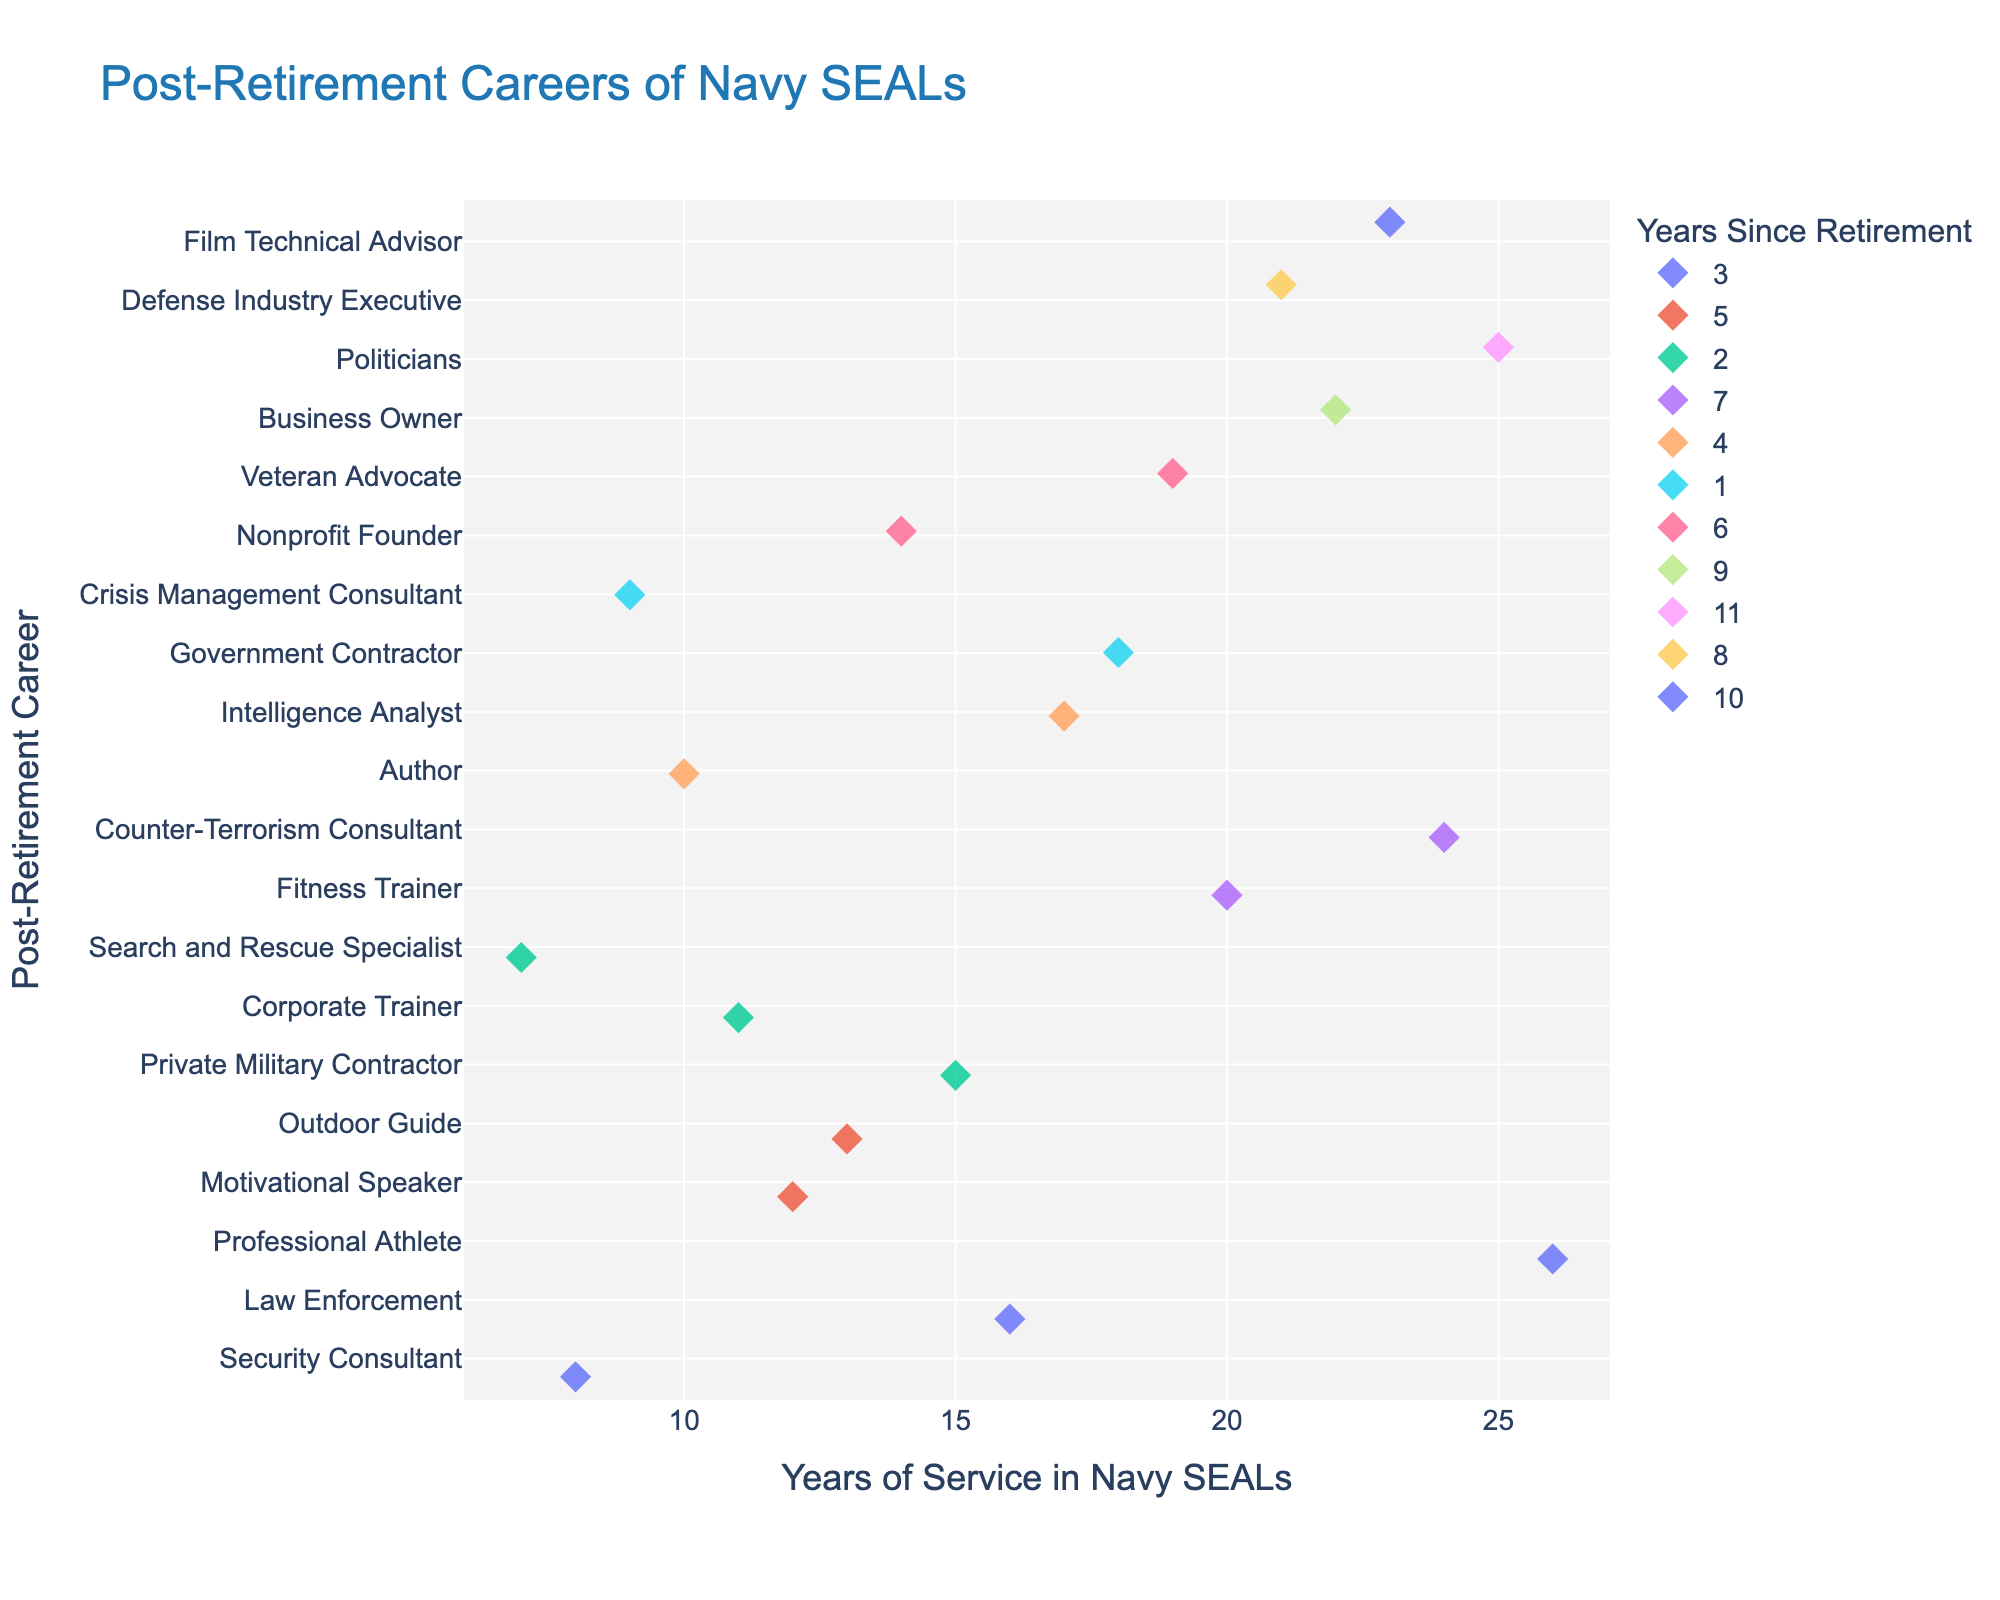What is the title of the plot? The title is usually found at the top of the plot. In this case, it is prominently displayed in a larger font.
Answer: Post-Retirement Careers of Navy SEALs What does the color of the markers represent? The color coding is explained in the legend which indicates the meaning of different colors. In this figure, colors represent the years since retirement.
Answer: The years since retirement How many Navy SEALs had a career as a "Fitness Trainer" post-retirement? Look for the "Fitness Trainer" label on the y-axis and count the corresponding markers.
Answer: One Which post-retirement career corresponds with exactly 25 years of service? Identify the marker aligned with 25 years of service on the x-axis, then look at its corresponding y-axis label.
Answer: Politician What is the range of years of service among former SEALs who became a "Nonprofit Founder"? Locate the "Nonprofit Founder" label on the y-axis and check the range of x-axis values for that label.
Answer: 14 years of service How many former SEALs retired after exactly 8 years of service? Find the markers positioned at 8 years of service along the x-axis and count them.
Answer: One Which post-retirement career has the highest number of data points? Count the number of markers for each career on the y-axis and identify which has the highest count.
Answer: Most careers have only one data point; no career has the highest number Who served the shortest duration in the Navy SEALs before retirement? Look for the smallest value on the x-axis that corresponds to a marker and check its y-axis label.
Answer: Search and Rescue Specialist (7 years) What is the average number of years of service for SEALs who became authors? Identify the "Author" label and find the corresponding x-axis value for the number of years of service, then compute the average.
Answer: 10 years (only one data point) Compare the years of service between "Government Contractor" and "Defense Industry Executive". Find both y-axis labels and compare their x-axis positions.
Answer: The Government Contractor had 18 years of service, while the Defense Industry Executive had 21 years 